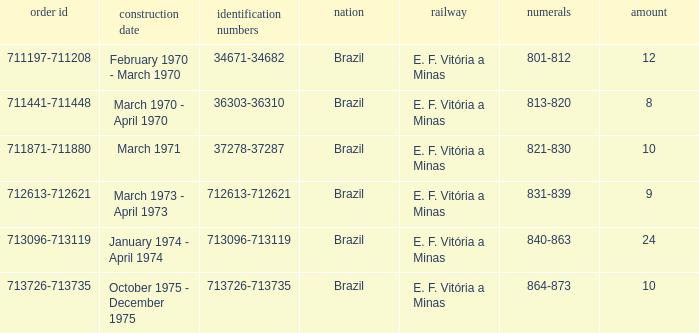How many railroads have the numbers 864-873? 1.0. 